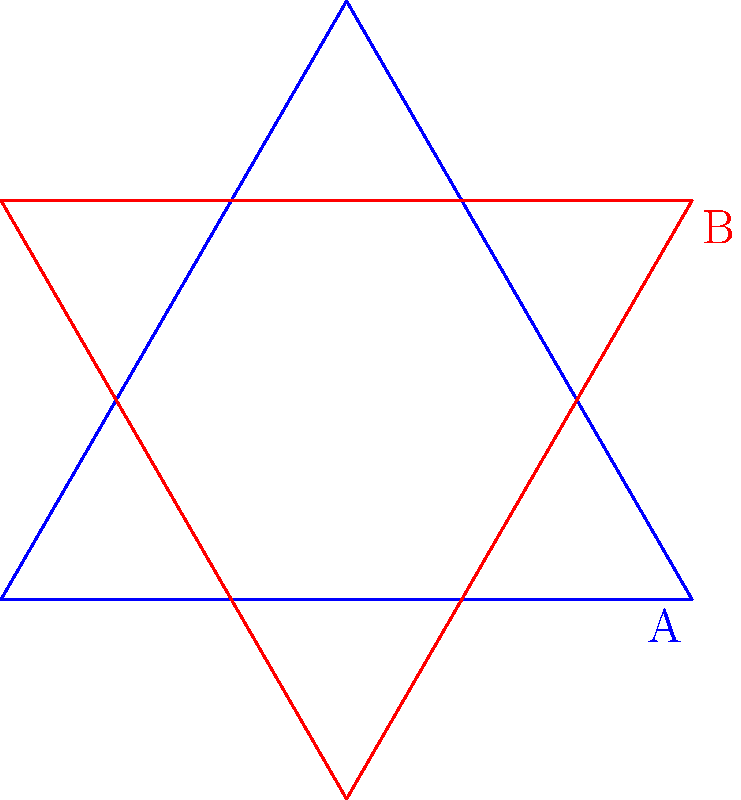Look at the two triangles above. If triangle A is rotated clockwise, how many degrees would it need to turn to match the orientation of triangle B? To solve this problem, we need to follow these steps:

1. Observe the initial orientation of triangle A (blue) and the final orientation of triangle B (red).

2. Notice that both triangles are equilateral, meaning all sides and angles are equal.

3. In an equilateral triangle, each internal angle is 60°.

4. To determine the rotation needed, we can count the number of 60° rotations between the two orientations.

5. Starting from triangle A and moving clockwise, we can see that one full 60° rotation is not enough to match triangle B's orientation.

6. We need to continue rotating for another 60° to align triangle A with triangle B.

7. Therefore, the total rotation required is 60° + 60° = 120°.

This mental rotation exercise helps us visualize and understand spatial relationships between objects, which is an important skill in various fields, including medical imaging and treatment planning.
Answer: 120° 